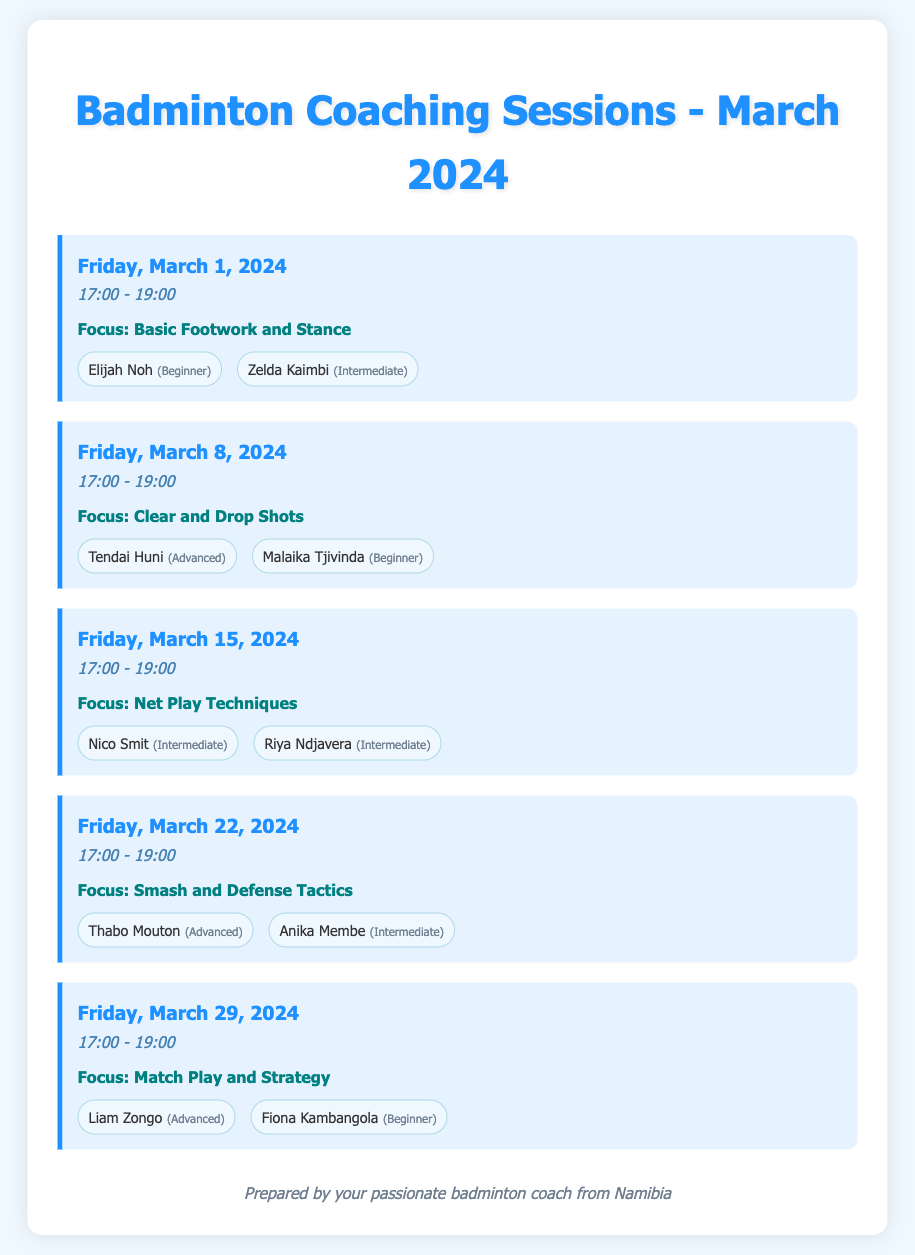What is the date of the first session? The date of the first session is found in the first session entry, which is Friday, March 1, 2024.
Answer: Friday, March 1, 2024 Who are the participants in the session on March 8? The participants for the session on March 8 are listed in the corresponding session entry. They are Tendai Huni and Malaika Tjivinda.
Answer: Tendai Huni, Malaika Tjivinda What is the focus of the session on March 22? The focus of the session on March 22 is specified in that session's entry as Smash and Defense Tactics.
Answer: Smash and Defense Tactics How many sessions are scheduled in March 2024? The total number of sessions can be counted from the document, which lists one session for each week in March.
Answer: Five What skill level is Elijah Noh? Elijah Noh's skill level is mentioned in the first session's participant list.
Answer: Beginner Which session focuses on Match Play and Strategy? The session focusing on Match Play and Strategy is detailed in the last entry of the document.
Answer: March 29, 2024 Who is the only beginner participant in the session on March 15? The participants in the session on March 15 are noted, and only one is a beginner.
Answer: None What time do all sessions start? The starting time for all sessions is consistently stated in the document as noted in each session entry.
Answer: 17:00 